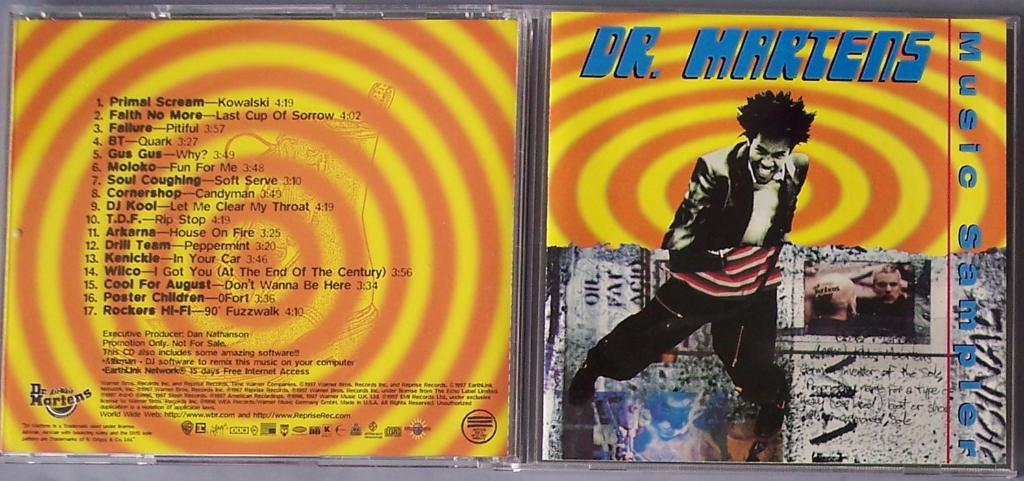<image>
Relay a brief, clear account of the picture shown. a Dr. Hartens cd that has many colors 